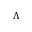<formula> <loc_0><loc_0><loc_500><loc_500>\Lambda</formula> 